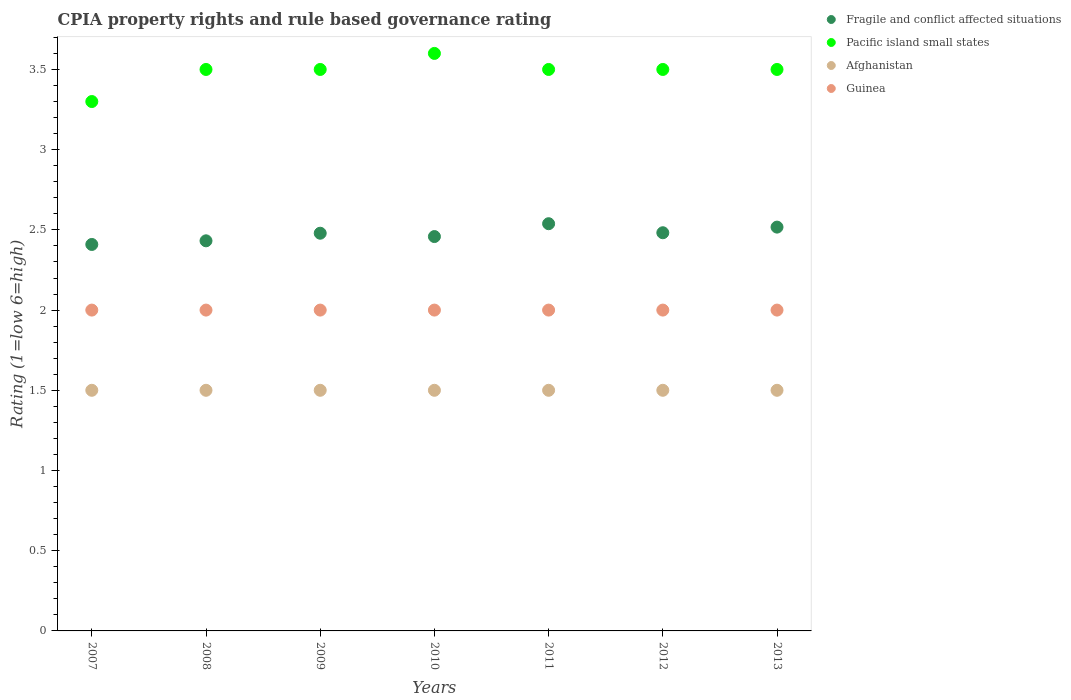How many different coloured dotlines are there?
Your answer should be compact. 4. Is the number of dotlines equal to the number of legend labels?
Offer a very short reply. Yes. What is the CPIA rating in Guinea in 2010?
Your answer should be very brief. 2. Across all years, what is the maximum CPIA rating in Pacific island small states?
Offer a terse response. 3.6. In which year was the CPIA rating in Pacific island small states maximum?
Provide a succinct answer. 2010. What is the difference between the CPIA rating in Fragile and conflict affected situations in 2009 and that in 2013?
Offer a terse response. -0.04. What is the difference between the CPIA rating in Guinea in 2010 and the CPIA rating in Fragile and conflict affected situations in 2009?
Keep it short and to the point. -0.48. In the year 2010, what is the difference between the CPIA rating in Fragile and conflict affected situations and CPIA rating in Guinea?
Provide a short and direct response. 0.46. What is the ratio of the CPIA rating in Afghanistan in 2008 to that in 2011?
Your answer should be very brief. 1. What is the difference between the highest and the second highest CPIA rating in Guinea?
Give a very brief answer. 0. What is the difference between the highest and the lowest CPIA rating in Pacific island small states?
Provide a short and direct response. 0.3. Does the CPIA rating in Pacific island small states monotonically increase over the years?
Offer a terse response. No. Is the CPIA rating in Afghanistan strictly less than the CPIA rating in Pacific island small states over the years?
Make the answer very short. Yes. How many dotlines are there?
Ensure brevity in your answer.  4. How many years are there in the graph?
Give a very brief answer. 7. Does the graph contain any zero values?
Your answer should be very brief. No. Does the graph contain grids?
Provide a succinct answer. No. What is the title of the graph?
Your response must be concise. CPIA property rights and rule based governance rating. Does "Grenada" appear as one of the legend labels in the graph?
Give a very brief answer. No. What is the label or title of the X-axis?
Keep it short and to the point. Years. What is the label or title of the Y-axis?
Give a very brief answer. Rating (1=low 6=high). What is the Rating (1=low 6=high) of Fragile and conflict affected situations in 2007?
Offer a terse response. 2.41. What is the Rating (1=low 6=high) in Guinea in 2007?
Your answer should be compact. 2. What is the Rating (1=low 6=high) of Fragile and conflict affected situations in 2008?
Make the answer very short. 2.43. What is the Rating (1=low 6=high) in Fragile and conflict affected situations in 2009?
Provide a succinct answer. 2.48. What is the Rating (1=low 6=high) in Pacific island small states in 2009?
Ensure brevity in your answer.  3.5. What is the Rating (1=low 6=high) of Guinea in 2009?
Ensure brevity in your answer.  2. What is the Rating (1=low 6=high) of Fragile and conflict affected situations in 2010?
Ensure brevity in your answer.  2.46. What is the Rating (1=low 6=high) of Pacific island small states in 2010?
Give a very brief answer. 3.6. What is the Rating (1=low 6=high) in Afghanistan in 2010?
Provide a short and direct response. 1.5. What is the Rating (1=low 6=high) of Guinea in 2010?
Ensure brevity in your answer.  2. What is the Rating (1=low 6=high) in Fragile and conflict affected situations in 2011?
Your answer should be very brief. 2.54. What is the Rating (1=low 6=high) in Pacific island small states in 2011?
Your answer should be compact. 3.5. What is the Rating (1=low 6=high) of Fragile and conflict affected situations in 2012?
Give a very brief answer. 2.48. What is the Rating (1=low 6=high) of Pacific island small states in 2012?
Your response must be concise. 3.5. What is the Rating (1=low 6=high) in Afghanistan in 2012?
Give a very brief answer. 1.5. What is the Rating (1=low 6=high) of Guinea in 2012?
Offer a very short reply. 2. What is the Rating (1=low 6=high) of Fragile and conflict affected situations in 2013?
Your response must be concise. 2.52. Across all years, what is the maximum Rating (1=low 6=high) of Fragile and conflict affected situations?
Offer a very short reply. 2.54. Across all years, what is the maximum Rating (1=low 6=high) of Pacific island small states?
Your answer should be compact. 3.6. Across all years, what is the maximum Rating (1=low 6=high) in Afghanistan?
Ensure brevity in your answer.  1.5. Across all years, what is the maximum Rating (1=low 6=high) of Guinea?
Provide a short and direct response. 2. Across all years, what is the minimum Rating (1=low 6=high) in Fragile and conflict affected situations?
Give a very brief answer. 2.41. Across all years, what is the minimum Rating (1=low 6=high) of Pacific island small states?
Ensure brevity in your answer.  3.3. Across all years, what is the minimum Rating (1=low 6=high) in Guinea?
Your answer should be compact. 2. What is the total Rating (1=low 6=high) in Fragile and conflict affected situations in the graph?
Ensure brevity in your answer.  17.32. What is the total Rating (1=low 6=high) in Pacific island small states in the graph?
Your answer should be very brief. 24.4. What is the total Rating (1=low 6=high) in Afghanistan in the graph?
Provide a short and direct response. 10.5. What is the difference between the Rating (1=low 6=high) in Fragile and conflict affected situations in 2007 and that in 2008?
Offer a terse response. -0.02. What is the difference between the Rating (1=low 6=high) of Pacific island small states in 2007 and that in 2008?
Give a very brief answer. -0.2. What is the difference between the Rating (1=low 6=high) in Guinea in 2007 and that in 2008?
Offer a terse response. 0. What is the difference between the Rating (1=low 6=high) in Fragile and conflict affected situations in 2007 and that in 2009?
Provide a short and direct response. -0.07. What is the difference between the Rating (1=low 6=high) in Pacific island small states in 2007 and that in 2009?
Offer a terse response. -0.2. What is the difference between the Rating (1=low 6=high) in Guinea in 2007 and that in 2009?
Make the answer very short. 0. What is the difference between the Rating (1=low 6=high) of Fragile and conflict affected situations in 2007 and that in 2010?
Your answer should be compact. -0.05. What is the difference between the Rating (1=low 6=high) in Guinea in 2007 and that in 2010?
Your answer should be very brief. 0. What is the difference between the Rating (1=low 6=high) of Fragile and conflict affected situations in 2007 and that in 2011?
Provide a succinct answer. -0.13. What is the difference between the Rating (1=low 6=high) of Afghanistan in 2007 and that in 2011?
Offer a very short reply. 0. What is the difference between the Rating (1=low 6=high) in Fragile and conflict affected situations in 2007 and that in 2012?
Keep it short and to the point. -0.07. What is the difference between the Rating (1=low 6=high) of Afghanistan in 2007 and that in 2012?
Provide a short and direct response. 0. What is the difference between the Rating (1=low 6=high) in Guinea in 2007 and that in 2012?
Keep it short and to the point. 0. What is the difference between the Rating (1=low 6=high) in Fragile and conflict affected situations in 2007 and that in 2013?
Ensure brevity in your answer.  -0.11. What is the difference between the Rating (1=low 6=high) in Guinea in 2007 and that in 2013?
Your answer should be compact. 0. What is the difference between the Rating (1=low 6=high) of Fragile and conflict affected situations in 2008 and that in 2009?
Your answer should be compact. -0.05. What is the difference between the Rating (1=low 6=high) of Pacific island small states in 2008 and that in 2009?
Your answer should be compact. 0. What is the difference between the Rating (1=low 6=high) in Fragile and conflict affected situations in 2008 and that in 2010?
Offer a very short reply. -0.03. What is the difference between the Rating (1=low 6=high) of Pacific island small states in 2008 and that in 2010?
Your response must be concise. -0.1. What is the difference between the Rating (1=low 6=high) in Afghanistan in 2008 and that in 2010?
Provide a succinct answer. 0. What is the difference between the Rating (1=low 6=high) of Fragile and conflict affected situations in 2008 and that in 2011?
Your answer should be very brief. -0.11. What is the difference between the Rating (1=low 6=high) in Pacific island small states in 2008 and that in 2011?
Offer a terse response. 0. What is the difference between the Rating (1=low 6=high) of Fragile and conflict affected situations in 2008 and that in 2012?
Your response must be concise. -0.05. What is the difference between the Rating (1=low 6=high) of Pacific island small states in 2008 and that in 2012?
Give a very brief answer. 0. What is the difference between the Rating (1=low 6=high) in Afghanistan in 2008 and that in 2012?
Offer a very short reply. 0. What is the difference between the Rating (1=low 6=high) in Fragile and conflict affected situations in 2008 and that in 2013?
Give a very brief answer. -0.09. What is the difference between the Rating (1=low 6=high) in Pacific island small states in 2008 and that in 2013?
Provide a short and direct response. 0. What is the difference between the Rating (1=low 6=high) in Afghanistan in 2008 and that in 2013?
Provide a short and direct response. 0. What is the difference between the Rating (1=low 6=high) of Guinea in 2008 and that in 2013?
Your answer should be very brief. 0. What is the difference between the Rating (1=low 6=high) in Fragile and conflict affected situations in 2009 and that in 2010?
Make the answer very short. 0.02. What is the difference between the Rating (1=low 6=high) of Pacific island small states in 2009 and that in 2010?
Your answer should be very brief. -0.1. What is the difference between the Rating (1=low 6=high) of Afghanistan in 2009 and that in 2010?
Keep it short and to the point. 0. What is the difference between the Rating (1=low 6=high) in Guinea in 2009 and that in 2010?
Your response must be concise. 0. What is the difference between the Rating (1=low 6=high) of Fragile and conflict affected situations in 2009 and that in 2011?
Ensure brevity in your answer.  -0.06. What is the difference between the Rating (1=low 6=high) in Pacific island small states in 2009 and that in 2011?
Offer a terse response. 0. What is the difference between the Rating (1=low 6=high) in Fragile and conflict affected situations in 2009 and that in 2012?
Ensure brevity in your answer.  -0. What is the difference between the Rating (1=low 6=high) in Afghanistan in 2009 and that in 2012?
Your response must be concise. 0. What is the difference between the Rating (1=low 6=high) of Fragile and conflict affected situations in 2009 and that in 2013?
Offer a very short reply. -0.04. What is the difference between the Rating (1=low 6=high) in Afghanistan in 2009 and that in 2013?
Provide a short and direct response. 0. What is the difference between the Rating (1=low 6=high) of Guinea in 2009 and that in 2013?
Offer a terse response. 0. What is the difference between the Rating (1=low 6=high) of Fragile and conflict affected situations in 2010 and that in 2011?
Provide a succinct answer. -0.08. What is the difference between the Rating (1=low 6=high) of Afghanistan in 2010 and that in 2011?
Make the answer very short. 0. What is the difference between the Rating (1=low 6=high) in Guinea in 2010 and that in 2011?
Your answer should be very brief. 0. What is the difference between the Rating (1=low 6=high) of Fragile and conflict affected situations in 2010 and that in 2012?
Your response must be concise. -0.02. What is the difference between the Rating (1=low 6=high) of Pacific island small states in 2010 and that in 2012?
Your answer should be very brief. 0.1. What is the difference between the Rating (1=low 6=high) in Afghanistan in 2010 and that in 2012?
Make the answer very short. 0. What is the difference between the Rating (1=low 6=high) in Guinea in 2010 and that in 2012?
Provide a succinct answer. 0. What is the difference between the Rating (1=low 6=high) in Fragile and conflict affected situations in 2010 and that in 2013?
Give a very brief answer. -0.06. What is the difference between the Rating (1=low 6=high) in Fragile and conflict affected situations in 2011 and that in 2012?
Provide a short and direct response. 0.06. What is the difference between the Rating (1=low 6=high) of Guinea in 2011 and that in 2012?
Your answer should be very brief. 0. What is the difference between the Rating (1=low 6=high) in Fragile and conflict affected situations in 2011 and that in 2013?
Offer a very short reply. 0.02. What is the difference between the Rating (1=low 6=high) of Fragile and conflict affected situations in 2012 and that in 2013?
Your answer should be very brief. -0.04. What is the difference between the Rating (1=low 6=high) in Pacific island small states in 2012 and that in 2013?
Your answer should be compact. 0. What is the difference between the Rating (1=low 6=high) in Afghanistan in 2012 and that in 2013?
Keep it short and to the point. 0. What is the difference between the Rating (1=low 6=high) in Fragile and conflict affected situations in 2007 and the Rating (1=low 6=high) in Pacific island small states in 2008?
Your answer should be compact. -1.09. What is the difference between the Rating (1=low 6=high) of Fragile and conflict affected situations in 2007 and the Rating (1=low 6=high) of Afghanistan in 2008?
Give a very brief answer. 0.91. What is the difference between the Rating (1=low 6=high) in Fragile and conflict affected situations in 2007 and the Rating (1=low 6=high) in Guinea in 2008?
Provide a succinct answer. 0.41. What is the difference between the Rating (1=low 6=high) of Pacific island small states in 2007 and the Rating (1=low 6=high) of Afghanistan in 2008?
Keep it short and to the point. 1.8. What is the difference between the Rating (1=low 6=high) of Pacific island small states in 2007 and the Rating (1=low 6=high) of Guinea in 2008?
Offer a very short reply. 1.3. What is the difference between the Rating (1=low 6=high) of Fragile and conflict affected situations in 2007 and the Rating (1=low 6=high) of Pacific island small states in 2009?
Provide a succinct answer. -1.09. What is the difference between the Rating (1=low 6=high) of Fragile and conflict affected situations in 2007 and the Rating (1=low 6=high) of Guinea in 2009?
Keep it short and to the point. 0.41. What is the difference between the Rating (1=low 6=high) in Pacific island small states in 2007 and the Rating (1=low 6=high) in Afghanistan in 2009?
Offer a terse response. 1.8. What is the difference between the Rating (1=low 6=high) in Afghanistan in 2007 and the Rating (1=low 6=high) in Guinea in 2009?
Keep it short and to the point. -0.5. What is the difference between the Rating (1=low 6=high) of Fragile and conflict affected situations in 2007 and the Rating (1=low 6=high) of Pacific island small states in 2010?
Keep it short and to the point. -1.19. What is the difference between the Rating (1=low 6=high) in Fragile and conflict affected situations in 2007 and the Rating (1=low 6=high) in Afghanistan in 2010?
Provide a succinct answer. 0.91. What is the difference between the Rating (1=low 6=high) in Fragile and conflict affected situations in 2007 and the Rating (1=low 6=high) in Guinea in 2010?
Your answer should be compact. 0.41. What is the difference between the Rating (1=low 6=high) in Pacific island small states in 2007 and the Rating (1=low 6=high) in Afghanistan in 2010?
Give a very brief answer. 1.8. What is the difference between the Rating (1=low 6=high) of Afghanistan in 2007 and the Rating (1=low 6=high) of Guinea in 2010?
Offer a very short reply. -0.5. What is the difference between the Rating (1=low 6=high) in Fragile and conflict affected situations in 2007 and the Rating (1=low 6=high) in Pacific island small states in 2011?
Offer a terse response. -1.09. What is the difference between the Rating (1=low 6=high) of Fragile and conflict affected situations in 2007 and the Rating (1=low 6=high) of Guinea in 2011?
Offer a terse response. 0.41. What is the difference between the Rating (1=low 6=high) of Afghanistan in 2007 and the Rating (1=low 6=high) of Guinea in 2011?
Ensure brevity in your answer.  -0.5. What is the difference between the Rating (1=low 6=high) of Fragile and conflict affected situations in 2007 and the Rating (1=low 6=high) of Pacific island small states in 2012?
Give a very brief answer. -1.09. What is the difference between the Rating (1=low 6=high) in Fragile and conflict affected situations in 2007 and the Rating (1=low 6=high) in Guinea in 2012?
Your answer should be very brief. 0.41. What is the difference between the Rating (1=low 6=high) of Pacific island small states in 2007 and the Rating (1=low 6=high) of Afghanistan in 2012?
Give a very brief answer. 1.8. What is the difference between the Rating (1=low 6=high) of Fragile and conflict affected situations in 2007 and the Rating (1=low 6=high) of Pacific island small states in 2013?
Offer a terse response. -1.09. What is the difference between the Rating (1=low 6=high) in Fragile and conflict affected situations in 2007 and the Rating (1=low 6=high) in Afghanistan in 2013?
Keep it short and to the point. 0.91. What is the difference between the Rating (1=low 6=high) in Fragile and conflict affected situations in 2007 and the Rating (1=low 6=high) in Guinea in 2013?
Your answer should be compact. 0.41. What is the difference between the Rating (1=low 6=high) in Pacific island small states in 2007 and the Rating (1=low 6=high) in Afghanistan in 2013?
Provide a short and direct response. 1.8. What is the difference between the Rating (1=low 6=high) in Pacific island small states in 2007 and the Rating (1=low 6=high) in Guinea in 2013?
Make the answer very short. 1.3. What is the difference between the Rating (1=low 6=high) of Afghanistan in 2007 and the Rating (1=low 6=high) of Guinea in 2013?
Your answer should be very brief. -0.5. What is the difference between the Rating (1=low 6=high) in Fragile and conflict affected situations in 2008 and the Rating (1=low 6=high) in Pacific island small states in 2009?
Give a very brief answer. -1.07. What is the difference between the Rating (1=low 6=high) of Fragile and conflict affected situations in 2008 and the Rating (1=low 6=high) of Afghanistan in 2009?
Provide a short and direct response. 0.93. What is the difference between the Rating (1=low 6=high) of Fragile and conflict affected situations in 2008 and the Rating (1=low 6=high) of Guinea in 2009?
Your answer should be very brief. 0.43. What is the difference between the Rating (1=low 6=high) of Afghanistan in 2008 and the Rating (1=low 6=high) of Guinea in 2009?
Provide a short and direct response. -0.5. What is the difference between the Rating (1=low 6=high) in Fragile and conflict affected situations in 2008 and the Rating (1=low 6=high) in Pacific island small states in 2010?
Your answer should be very brief. -1.17. What is the difference between the Rating (1=low 6=high) of Fragile and conflict affected situations in 2008 and the Rating (1=low 6=high) of Afghanistan in 2010?
Your answer should be very brief. 0.93. What is the difference between the Rating (1=low 6=high) in Fragile and conflict affected situations in 2008 and the Rating (1=low 6=high) in Guinea in 2010?
Keep it short and to the point. 0.43. What is the difference between the Rating (1=low 6=high) of Afghanistan in 2008 and the Rating (1=low 6=high) of Guinea in 2010?
Your response must be concise. -0.5. What is the difference between the Rating (1=low 6=high) of Fragile and conflict affected situations in 2008 and the Rating (1=low 6=high) of Pacific island small states in 2011?
Make the answer very short. -1.07. What is the difference between the Rating (1=low 6=high) of Fragile and conflict affected situations in 2008 and the Rating (1=low 6=high) of Afghanistan in 2011?
Make the answer very short. 0.93. What is the difference between the Rating (1=low 6=high) of Fragile and conflict affected situations in 2008 and the Rating (1=low 6=high) of Guinea in 2011?
Offer a terse response. 0.43. What is the difference between the Rating (1=low 6=high) of Afghanistan in 2008 and the Rating (1=low 6=high) of Guinea in 2011?
Ensure brevity in your answer.  -0.5. What is the difference between the Rating (1=low 6=high) in Fragile and conflict affected situations in 2008 and the Rating (1=low 6=high) in Pacific island small states in 2012?
Your answer should be compact. -1.07. What is the difference between the Rating (1=low 6=high) in Fragile and conflict affected situations in 2008 and the Rating (1=low 6=high) in Afghanistan in 2012?
Keep it short and to the point. 0.93. What is the difference between the Rating (1=low 6=high) in Fragile and conflict affected situations in 2008 and the Rating (1=low 6=high) in Guinea in 2012?
Offer a very short reply. 0.43. What is the difference between the Rating (1=low 6=high) in Pacific island small states in 2008 and the Rating (1=low 6=high) in Afghanistan in 2012?
Give a very brief answer. 2. What is the difference between the Rating (1=low 6=high) in Pacific island small states in 2008 and the Rating (1=low 6=high) in Guinea in 2012?
Provide a succinct answer. 1.5. What is the difference between the Rating (1=low 6=high) of Fragile and conflict affected situations in 2008 and the Rating (1=low 6=high) of Pacific island small states in 2013?
Keep it short and to the point. -1.07. What is the difference between the Rating (1=low 6=high) in Fragile and conflict affected situations in 2008 and the Rating (1=low 6=high) in Afghanistan in 2013?
Keep it short and to the point. 0.93. What is the difference between the Rating (1=low 6=high) in Fragile and conflict affected situations in 2008 and the Rating (1=low 6=high) in Guinea in 2013?
Make the answer very short. 0.43. What is the difference between the Rating (1=low 6=high) in Pacific island small states in 2008 and the Rating (1=low 6=high) in Guinea in 2013?
Provide a short and direct response. 1.5. What is the difference between the Rating (1=low 6=high) in Fragile and conflict affected situations in 2009 and the Rating (1=low 6=high) in Pacific island small states in 2010?
Offer a terse response. -1.12. What is the difference between the Rating (1=low 6=high) of Fragile and conflict affected situations in 2009 and the Rating (1=low 6=high) of Afghanistan in 2010?
Your response must be concise. 0.98. What is the difference between the Rating (1=low 6=high) in Fragile and conflict affected situations in 2009 and the Rating (1=low 6=high) in Guinea in 2010?
Make the answer very short. 0.48. What is the difference between the Rating (1=low 6=high) in Pacific island small states in 2009 and the Rating (1=low 6=high) in Afghanistan in 2010?
Your answer should be compact. 2. What is the difference between the Rating (1=low 6=high) of Pacific island small states in 2009 and the Rating (1=low 6=high) of Guinea in 2010?
Make the answer very short. 1.5. What is the difference between the Rating (1=low 6=high) of Afghanistan in 2009 and the Rating (1=low 6=high) of Guinea in 2010?
Provide a succinct answer. -0.5. What is the difference between the Rating (1=low 6=high) of Fragile and conflict affected situations in 2009 and the Rating (1=low 6=high) of Pacific island small states in 2011?
Keep it short and to the point. -1.02. What is the difference between the Rating (1=low 6=high) of Fragile and conflict affected situations in 2009 and the Rating (1=low 6=high) of Afghanistan in 2011?
Provide a succinct answer. 0.98. What is the difference between the Rating (1=low 6=high) in Fragile and conflict affected situations in 2009 and the Rating (1=low 6=high) in Guinea in 2011?
Offer a very short reply. 0.48. What is the difference between the Rating (1=low 6=high) in Pacific island small states in 2009 and the Rating (1=low 6=high) in Afghanistan in 2011?
Offer a very short reply. 2. What is the difference between the Rating (1=low 6=high) of Pacific island small states in 2009 and the Rating (1=low 6=high) of Guinea in 2011?
Provide a succinct answer. 1.5. What is the difference between the Rating (1=low 6=high) in Fragile and conflict affected situations in 2009 and the Rating (1=low 6=high) in Pacific island small states in 2012?
Your answer should be compact. -1.02. What is the difference between the Rating (1=low 6=high) in Fragile and conflict affected situations in 2009 and the Rating (1=low 6=high) in Afghanistan in 2012?
Your response must be concise. 0.98. What is the difference between the Rating (1=low 6=high) of Fragile and conflict affected situations in 2009 and the Rating (1=low 6=high) of Guinea in 2012?
Your answer should be very brief. 0.48. What is the difference between the Rating (1=low 6=high) of Pacific island small states in 2009 and the Rating (1=low 6=high) of Afghanistan in 2012?
Ensure brevity in your answer.  2. What is the difference between the Rating (1=low 6=high) of Afghanistan in 2009 and the Rating (1=low 6=high) of Guinea in 2012?
Keep it short and to the point. -0.5. What is the difference between the Rating (1=low 6=high) in Fragile and conflict affected situations in 2009 and the Rating (1=low 6=high) in Pacific island small states in 2013?
Provide a short and direct response. -1.02. What is the difference between the Rating (1=low 6=high) in Fragile and conflict affected situations in 2009 and the Rating (1=low 6=high) in Afghanistan in 2013?
Provide a short and direct response. 0.98. What is the difference between the Rating (1=low 6=high) of Fragile and conflict affected situations in 2009 and the Rating (1=low 6=high) of Guinea in 2013?
Offer a terse response. 0.48. What is the difference between the Rating (1=low 6=high) of Pacific island small states in 2009 and the Rating (1=low 6=high) of Afghanistan in 2013?
Your response must be concise. 2. What is the difference between the Rating (1=low 6=high) in Fragile and conflict affected situations in 2010 and the Rating (1=low 6=high) in Pacific island small states in 2011?
Your response must be concise. -1.04. What is the difference between the Rating (1=low 6=high) of Fragile and conflict affected situations in 2010 and the Rating (1=low 6=high) of Guinea in 2011?
Your answer should be compact. 0.46. What is the difference between the Rating (1=low 6=high) in Pacific island small states in 2010 and the Rating (1=low 6=high) in Guinea in 2011?
Make the answer very short. 1.6. What is the difference between the Rating (1=low 6=high) of Afghanistan in 2010 and the Rating (1=low 6=high) of Guinea in 2011?
Your response must be concise. -0.5. What is the difference between the Rating (1=low 6=high) of Fragile and conflict affected situations in 2010 and the Rating (1=low 6=high) of Pacific island small states in 2012?
Give a very brief answer. -1.04. What is the difference between the Rating (1=low 6=high) in Fragile and conflict affected situations in 2010 and the Rating (1=low 6=high) in Afghanistan in 2012?
Your answer should be very brief. 0.96. What is the difference between the Rating (1=low 6=high) of Fragile and conflict affected situations in 2010 and the Rating (1=low 6=high) of Guinea in 2012?
Provide a short and direct response. 0.46. What is the difference between the Rating (1=low 6=high) of Pacific island small states in 2010 and the Rating (1=low 6=high) of Guinea in 2012?
Provide a succinct answer. 1.6. What is the difference between the Rating (1=low 6=high) in Afghanistan in 2010 and the Rating (1=low 6=high) in Guinea in 2012?
Make the answer very short. -0.5. What is the difference between the Rating (1=low 6=high) in Fragile and conflict affected situations in 2010 and the Rating (1=low 6=high) in Pacific island small states in 2013?
Your answer should be compact. -1.04. What is the difference between the Rating (1=low 6=high) of Fragile and conflict affected situations in 2010 and the Rating (1=low 6=high) of Guinea in 2013?
Your response must be concise. 0.46. What is the difference between the Rating (1=low 6=high) of Pacific island small states in 2010 and the Rating (1=low 6=high) of Guinea in 2013?
Your answer should be very brief. 1.6. What is the difference between the Rating (1=low 6=high) of Fragile and conflict affected situations in 2011 and the Rating (1=low 6=high) of Pacific island small states in 2012?
Make the answer very short. -0.96. What is the difference between the Rating (1=low 6=high) of Fragile and conflict affected situations in 2011 and the Rating (1=low 6=high) of Afghanistan in 2012?
Ensure brevity in your answer.  1.04. What is the difference between the Rating (1=low 6=high) in Fragile and conflict affected situations in 2011 and the Rating (1=low 6=high) in Guinea in 2012?
Provide a succinct answer. 0.54. What is the difference between the Rating (1=low 6=high) in Pacific island small states in 2011 and the Rating (1=low 6=high) in Afghanistan in 2012?
Keep it short and to the point. 2. What is the difference between the Rating (1=low 6=high) in Afghanistan in 2011 and the Rating (1=low 6=high) in Guinea in 2012?
Provide a succinct answer. -0.5. What is the difference between the Rating (1=low 6=high) of Fragile and conflict affected situations in 2011 and the Rating (1=low 6=high) of Pacific island small states in 2013?
Make the answer very short. -0.96. What is the difference between the Rating (1=low 6=high) in Fragile and conflict affected situations in 2011 and the Rating (1=low 6=high) in Afghanistan in 2013?
Give a very brief answer. 1.04. What is the difference between the Rating (1=low 6=high) in Fragile and conflict affected situations in 2011 and the Rating (1=low 6=high) in Guinea in 2013?
Offer a very short reply. 0.54. What is the difference between the Rating (1=low 6=high) in Afghanistan in 2011 and the Rating (1=low 6=high) in Guinea in 2013?
Offer a very short reply. -0.5. What is the difference between the Rating (1=low 6=high) in Fragile and conflict affected situations in 2012 and the Rating (1=low 6=high) in Pacific island small states in 2013?
Make the answer very short. -1.02. What is the difference between the Rating (1=low 6=high) in Fragile and conflict affected situations in 2012 and the Rating (1=low 6=high) in Afghanistan in 2013?
Your answer should be compact. 0.98. What is the difference between the Rating (1=low 6=high) in Fragile and conflict affected situations in 2012 and the Rating (1=low 6=high) in Guinea in 2013?
Offer a very short reply. 0.48. What is the difference between the Rating (1=low 6=high) of Pacific island small states in 2012 and the Rating (1=low 6=high) of Guinea in 2013?
Your response must be concise. 1.5. What is the difference between the Rating (1=low 6=high) of Afghanistan in 2012 and the Rating (1=low 6=high) of Guinea in 2013?
Your answer should be very brief. -0.5. What is the average Rating (1=low 6=high) of Fragile and conflict affected situations per year?
Provide a short and direct response. 2.47. What is the average Rating (1=low 6=high) in Pacific island small states per year?
Ensure brevity in your answer.  3.49. In the year 2007, what is the difference between the Rating (1=low 6=high) in Fragile and conflict affected situations and Rating (1=low 6=high) in Pacific island small states?
Your answer should be very brief. -0.89. In the year 2007, what is the difference between the Rating (1=low 6=high) of Fragile and conflict affected situations and Rating (1=low 6=high) of Afghanistan?
Give a very brief answer. 0.91. In the year 2007, what is the difference between the Rating (1=low 6=high) in Fragile and conflict affected situations and Rating (1=low 6=high) in Guinea?
Provide a short and direct response. 0.41. In the year 2008, what is the difference between the Rating (1=low 6=high) of Fragile and conflict affected situations and Rating (1=low 6=high) of Pacific island small states?
Your answer should be very brief. -1.07. In the year 2008, what is the difference between the Rating (1=low 6=high) in Fragile and conflict affected situations and Rating (1=low 6=high) in Afghanistan?
Give a very brief answer. 0.93. In the year 2008, what is the difference between the Rating (1=low 6=high) in Fragile and conflict affected situations and Rating (1=low 6=high) in Guinea?
Your response must be concise. 0.43. In the year 2008, what is the difference between the Rating (1=low 6=high) in Pacific island small states and Rating (1=low 6=high) in Afghanistan?
Your answer should be compact. 2. In the year 2008, what is the difference between the Rating (1=low 6=high) in Afghanistan and Rating (1=low 6=high) in Guinea?
Offer a very short reply. -0.5. In the year 2009, what is the difference between the Rating (1=low 6=high) in Fragile and conflict affected situations and Rating (1=low 6=high) in Pacific island small states?
Provide a succinct answer. -1.02. In the year 2009, what is the difference between the Rating (1=low 6=high) in Fragile and conflict affected situations and Rating (1=low 6=high) in Afghanistan?
Provide a succinct answer. 0.98. In the year 2009, what is the difference between the Rating (1=low 6=high) of Fragile and conflict affected situations and Rating (1=low 6=high) of Guinea?
Give a very brief answer. 0.48. In the year 2009, what is the difference between the Rating (1=low 6=high) in Pacific island small states and Rating (1=low 6=high) in Afghanistan?
Provide a succinct answer. 2. In the year 2009, what is the difference between the Rating (1=low 6=high) in Pacific island small states and Rating (1=low 6=high) in Guinea?
Ensure brevity in your answer.  1.5. In the year 2009, what is the difference between the Rating (1=low 6=high) of Afghanistan and Rating (1=low 6=high) of Guinea?
Your answer should be very brief. -0.5. In the year 2010, what is the difference between the Rating (1=low 6=high) in Fragile and conflict affected situations and Rating (1=low 6=high) in Pacific island small states?
Offer a terse response. -1.14. In the year 2010, what is the difference between the Rating (1=low 6=high) in Fragile and conflict affected situations and Rating (1=low 6=high) in Guinea?
Your response must be concise. 0.46. In the year 2010, what is the difference between the Rating (1=low 6=high) of Pacific island small states and Rating (1=low 6=high) of Afghanistan?
Provide a short and direct response. 2.1. In the year 2010, what is the difference between the Rating (1=low 6=high) of Afghanistan and Rating (1=low 6=high) of Guinea?
Offer a terse response. -0.5. In the year 2011, what is the difference between the Rating (1=low 6=high) of Fragile and conflict affected situations and Rating (1=low 6=high) of Pacific island small states?
Give a very brief answer. -0.96. In the year 2011, what is the difference between the Rating (1=low 6=high) in Fragile and conflict affected situations and Rating (1=low 6=high) in Guinea?
Ensure brevity in your answer.  0.54. In the year 2011, what is the difference between the Rating (1=low 6=high) of Pacific island small states and Rating (1=low 6=high) of Guinea?
Provide a succinct answer. 1.5. In the year 2011, what is the difference between the Rating (1=low 6=high) of Afghanistan and Rating (1=low 6=high) of Guinea?
Ensure brevity in your answer.  -0.5. In the year 2012, what is the difference between the Rating (1=low 6=high) of Fragile and conflict affected situations and Rating (1=low 6=high) of Pacific island small states?
Your response must be concise. -1.02. In the year 2012, what is the difference between the Rating (1=low 6=high) in Fragile and conflict affected situations and Rating (1=low 6=high) in Afghanistan?
Provide a succinct answer. 0.98. In the year 2012, what is the difference between the Rating (1=low 6=high) in Fragile and conflict affected situations and Rating (1=low 6=high) in Guinea?
Provide a short and direct response. 0.48. In the year 2012, what is the difference between the Rating (1=low 6=high) in Pacific island small states and Rating (1=low 6=high) in Afghanistan?
Your response must be concise. 2. In the year 2012, what is the difference between the Rating (1=low 6=high) in Pacific island small states and Rating (1=low 6=high) in Guinea?
Ensure brevity in your answer.  1.5. In the year 2013, what is the difference between the Rating (1=low 6=high) of Fragile and conflict affected situations and Rating (1=low 6=high) of Pacific island small states?
Your response must be concise. -0.98. In the year 2013, what is the difference between the Rating (1=low 6=high) in Fragile and conflict affected situations and Rating (1=low 6=high) in Afghanistan?
Your answer should be compact. 1.02. In the year 2013, what is the difference between the Rating (1=low 6=high) in Fragile and conflict affected situations and Rating (1=low 6=high) in Guinea?
Offer a terse response. 0.52. What is the ratio of the Rating (1=low 6=high) in Pacific island small states in 2007 to that in 2008?
Make the answer very short. 0.94. What is the ratio of the Rating (1=low 6=high) in Afghanistan in 2007 to that in 2008?
Provide a succinct answer. 1. What is the ratio of the Rating (1=low 6=high) in Fragile and conflict affected situations in 2007 to that in 2009?
Your answer should be very brief. 0.97. What is the ratio of the Rating (1=low 6=high) of Pacific island small states in 2007 to that in 2009?
Provide a succinct answer. 0.94. What is the ratio of the Rating (1=low 6=high) in Afghanistan in 2007 to that in 2009?
Ensure brevity in your answer.  1. What is the ratio of the Rating (1=low 6=high) of Guinea in 2007 to that in 2009?
Offer a very short reply. 1. What is the ratio of the Rating (1=low 6=high) in Pacific island small states in 2007 to that in 2010?
Make the answer very short. 0.92. What is the ratio of the Rating (1=low 6=high) of Fragile and conflict affected situations in 2007 to that in 2011?
Your response must be concise. 0.95. What is the ratio of the Rating (1=low 6=high) of Pacific island small states in 2007 to that in 2011?
Your response must be concise. 0.94. What is the ratio of the Rating (1=low 6=high) of Afghanistan in 2007 to that in 2011?
Provide a succinct answer. 1. What is the ratio of the Rating (1=low 6=high) of Guinea in 2007 to that in 2011?
Offer a terse response. 1. What is the ratio of the Rating (1=low 6=high) of Fragile and conflict affected situations in 2007 to that in 2012?
Give a very brief answer. 0.97. What is the ratio of the Rating (1=low 6=high) in Pacific island small states in 2007 to that in 2012?
Offer a very short reply. 0.94. What is the ratio of the Rating (1=low 6=high) of Afghanistan in 2007 to that in 2012?
Give a very brief answer. 1. What is the ratio of the Rating (1=low 6=high) in Fragile and conflict affected situations in 2007 to that in 2013?
Your response must be concise. 0.96. What is the ratio of the Rating (1=low 6=high) of Pacific island small states in 2007 to that in 2013?
Provide a short and direct response. 0.94. What is the ratio of the Rating (1=low 6=high) in Afghanistan in 2007 to that in 2013?
Give a very brief answer. 1. What is the ratio of the Rating (1=low 6=high) of Fragile and conflict affected situations in 2008 to that in 2009?
Your response must be concise. 0.98. What is the ratio of the Rating (1=low 6=high) in Pacific island small states in 2008 to that in 2009?
Make the answer very short. 1. What is the ratio of the Rating (1=low 6=high) of Afghanistan in 2008 to that in 2009?
Your answer should be compact. 1. What is the ratio of the Rating (1=low 6=high) in Guinea in 2008 to that in 2009?
Keep it short and to the point. 1. What is the ratio of the Rating (1=low 6=high) in Fragile and conflict affected situations in 2008 to that in 2010?
Offer a very short reply. 0.99. What is the ratio of the Rating (1=low 6=high) of Pacific island small states in 2008 to that in 2010?
Give a very brief answer. 0.97. What is the ratio of the Rating (1=low 6=high) in Guinea in 2008 to that in 2010?
Your answer should be compact. 1. What is the ratio of the Rating (1=low 6=high) in Fragile and conflict affected situations in 2008 to that in 2011?
Make the answer very short. 0.96. What is the ratio of the Rating (1=low 6=high) of Pacific island small states in 2008 to that in 2011?
Your answer should be very brief. 1. What is the ratio of the Rating (1=low 6=high) of Afghanistan in 2008 to that in 2011?
Offer a very short reply. 1. What is the ratio of the Rating (1=low 6=high) in Fragile and conflict affected situations in 2008 to that in 2012?
Keep it short and to the point. 0.98. What is the ratio of the Rating (1=low 6=high) in Fragile and conflict affected situations in 2008 to that in 2013?
Keep it short and to the point. 0.97. What is the ratio of the Rating (1=low 6=high) of Pacific island small states in 2008 to that in 2013?
Keep it short and to the point. 1. What is the ratio of the Rating (1=low 6=high) of Guinea in 2008 to that in 2013?
Provide a succinct answer. 1. What is the ratio of the Rating (1=low 6=high) in Fragile and conflict affected situations in 2009 to that in 2010?
Offer a very short reply. 1.01. What is the ratio of the Rating (1=low 6=high) of Pacific island small states in 2009 to that in 2010?
Keep it short and to the point. 0.97. What is the ratio of the Rating (1=low 6=high) in Guinea in 2009 to that in 2010?
Keep it short and to the point. 1. What is the ratio of the Rating (1=low 6=high) in Fragile and conflict affected situations in 2009 to that in 2011?
Your answer should be very brief. 0.98. What is the ratio of the Rating (1=low 6=high) of Afghanistan in 2009 to that in 2011?
Provide a succinct answer. 1. What is the ratio of the Rating (1=low 6=high) in Guinea in 2009 to that in 2011?
Your answer should be compact. 1. What is the ratio of the Rating (1=low 6=high) in Fragile and conflict affected situations in 2009 to that in 2012?
Provide a short and direct response. 1. What is the ratio of the Rating (1=low 6=high) of Pacific island small states in 2009 to that in 2012?
Give a very brief answer. 1. What is the ratio of the Rating (1=low 6=high) of Fragile and conflict affected situations in 2009 to that in 2013?
Give a very brief answer. 0.98. What is the ratio of the Rating (1=low 6=high) of Afghanistan in 2009 to that in 2013?
Provide a succinct answer. 1. What is the ratio of the Rating (1=low 6=high) of Guinea in 2009 to that in 2013?
Give a very brief answer. 1. What is the ratio of the Rating (1=low 6=high) of Fragile and conflict affected situations in 2010 to that in 2011?
Offer a very short reply. 0.97. What is the ratio of the Rating (1=low 6=high) of Pacific island small states in 2010 to that in 2011?
Give a very brief answer. 1.03. What is the ratio of the Rating (1=low 6=high) of Guinea in 2010 to that in 2011?
Keep it short and to the point. 1. What is the ratio of the Rating (1=low 6=high) of Fragile and conflict affected situations in 2010 to that in 2012?
Make the answer very short. 0.99. What is the ratio of the Rating (1=low 6=high) of Pacific island small states in 2010 to that in 2012?
Provide a succinct answer. 1.03. What is the ratio of the Rating (1=low 6=high) of Guinea in 2010 to that in 2012?
Keep it short and to the point. 1. What is the ratio of the Rating (1=low 6=high) in Fragile and conflict affected situations in 2010 to that in 2013?
Your response must be concise. 0.98. What is the ratio of the Rating (1=low 6=high) of Pacific island small states in 2010 to that in 2013?
Keep it short and to the point. 1.03. What is the ratio of the Rating (1=low 6=high) in Afghanistan in 2010 to that in 2013?
Make the answer very short. 1. What is the ratio of the Rating (1=low 6=high) in Guinea in 2010 to that in 2013?
Offer a very short reply. 1. What is the ratio of the Rating (1=low 6=high) in Fragile and conflict affected situations in 2011 to that in 2012?
Your answer should be very brief. 1.02. What is the ratio of the Rating (1=low 6=high) in Afghanistan in 2011 to that in 2012?
Your answer should be very brief. 1. What is the ratio of the Rating (1=low 6=high) in Guinea in 2011 to that in 2012?
Your answer should be compact. 1. What is the ratio of the Rating (1=low 6=high) in Fragile and conflict affected situations in 2011 to that in 2013?
Your answer should be very brief. 1.01. What is the ratio of the Rating (1=low 6=high) in Pacific island small states in 2011 to that in 2013?
Offer a very short reply. 1. What is the ratio of the Rating (1=low 6=high) of Afghanistan in 2011 to that in 2013?
Your response must be concise. 1. What is the ratio of the Rating (1=low 6=high) of Guinea in 2011 to that in 2013?
Offer a terse response. 1. What is the ratio of the Rating (1=low 6=high) of Fragile and conflict affected situations in 2012 to that in 2013?
Provide a succinct answer. 0.99. What is the ratio of the Rating (1=low 6=high) in Guinea in 2012 to that in 2013?
Your response must be concise. 1. What is the difference between the highest and the second highest Rating (1=low 6=high) in Fragile and conflict affected situations?
Offer a very short reply. 0.02. What is the difference between the highest and the second highest Rating (1=low 6=high) of Pacific island small states?
Ensure brevity in your answer.  0.1. What is the difference between the highest and the second highest Rating (1=low 6=high) of Afghanistan?
Offer a very short reply. 0. What is the difference between the highest and the lowest Rating (1=low 6=high) in Fragile and conflict affected situations?
Make the answer very short. 0.13. What is the difference between the highest and the lowest Rating (1=low 6=high) of Pacific island small states?
Offer a terse response. 0.3. What is the difference between the highest and the lowest Rating (1=low 6=high) in Afghanistan?
Give a very brief answer. 0. What is the difference between the highest and the lowest Rating (1=low 6=high) in Guinea?
Your response must be concise. 0. 